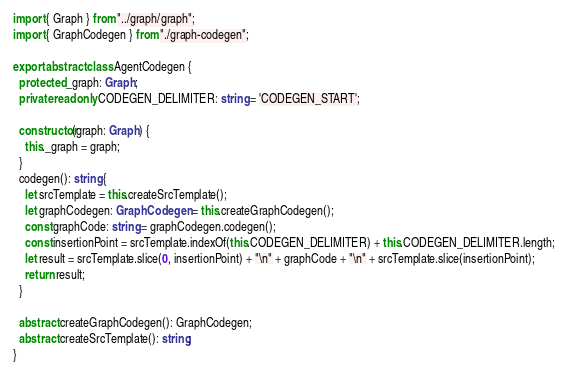<code> <loc_0><loc_0><loc_500><loc_500><_TypeScript_>import { Graph } from "../graph/graph";
import { GraphCodegen } from "./graph-codegen";

export abstract class AgentCodegen {
  protected _graph: Graph;
  private readonly CODEGEN_DELIMITER: string = 'CODEGEN_START';

  constructor(graph: Graph) {
    this._graph = graph;
  }
  codegen(): string {
    let srcTemplate = this.createSrcTemplate();
    let graphCodegen: GraphCodegen = this.createGraphCodegen();
    const graphCode: string = graphCodegen.codegen();
    const insertionPoint = srcTemplate.indexOf(this.CODEGEN_DELIMITER) + this.CODEGEN_DELIMITER.length;
    let result = srcTemplate.slice(0, insertionPoint) + "\n" + graphCode + "\n" + srcTemplate.slice(insertionPoint);    
    return result;
  }

  abstract createGraphCodegen(): GraphCodegen;
  abstract createSrcTemplate(): string;
}</code> 